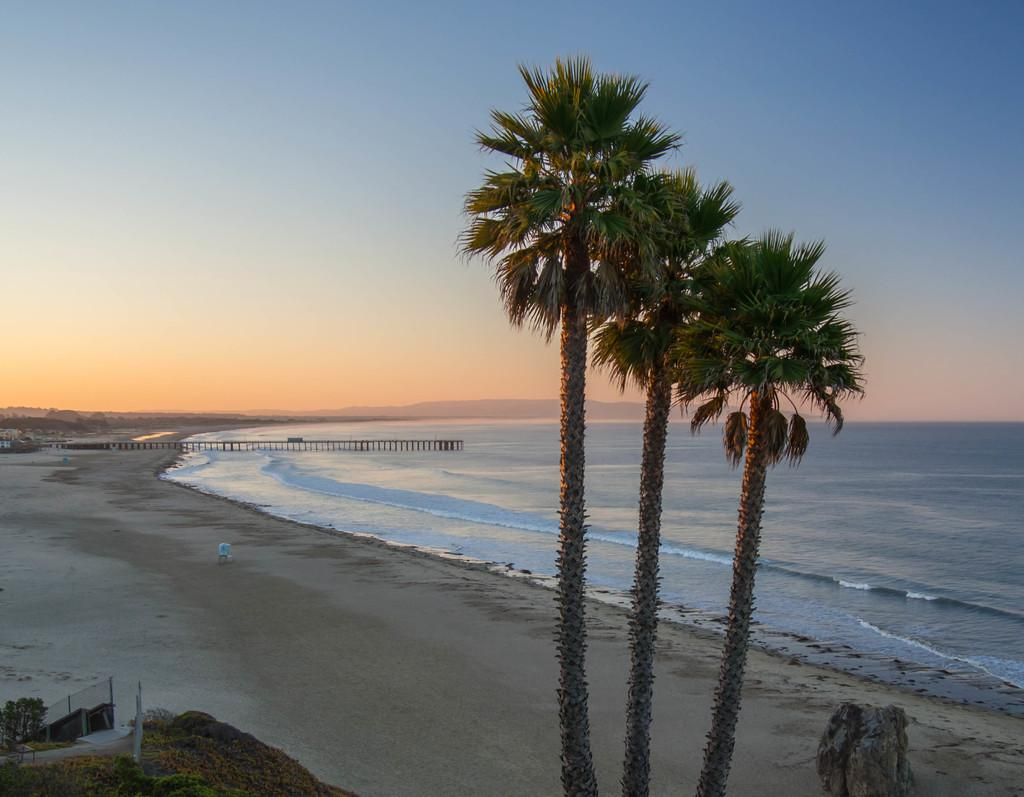How many trees can be seen in the image? There are three trees in the image. What type of natural environment is depicted at the bottom of the image? There is a beach area at the bottom of the image. What body of water is visible in the middle of the image? There is a sea in the middle of the image. What is visible at the top of the image? The sky is at the top of the image. What type of cloth is being used in the protest in the image? There is no protest or cloth present in the image; it features three trees, a beach area, a sea, and a sky. 